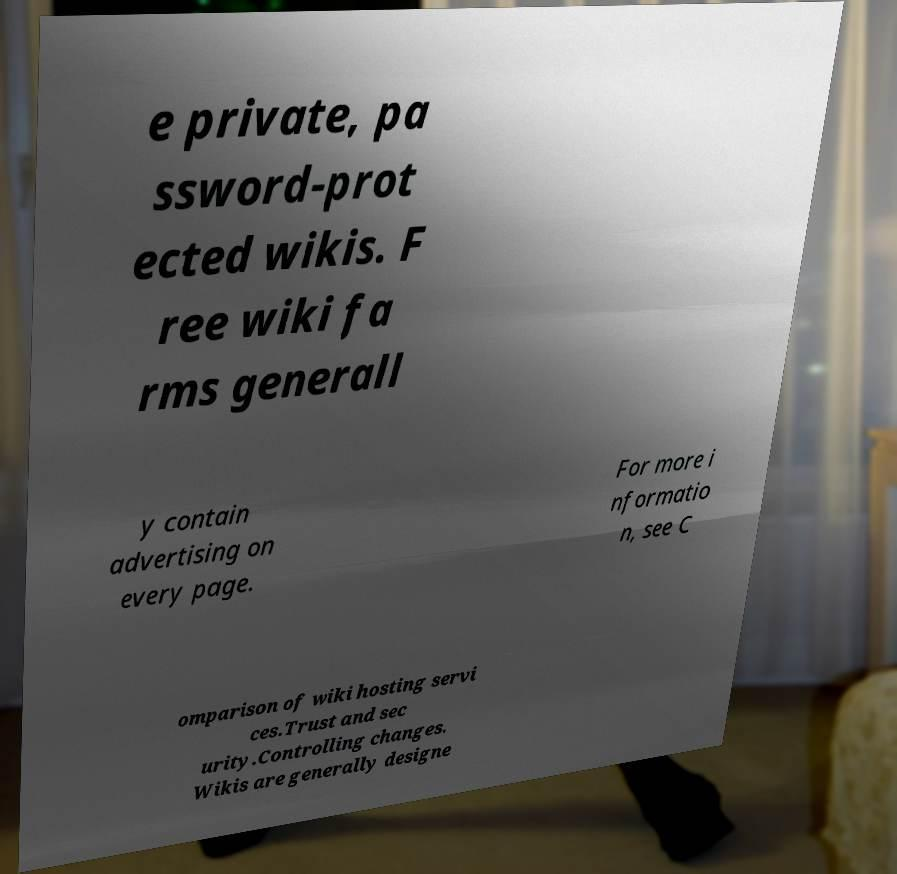For documentation purposes, I need the text within this image transcribed. Could you provide that? e private, pa ssword-prot ected wikis. F ree wiki fa rms generall y contain advertising on every page. For more i nformatio n, see C omparison of wiki hosting servi ces.Trust and sec urity.Controlling changes. Wikis are generally designe 